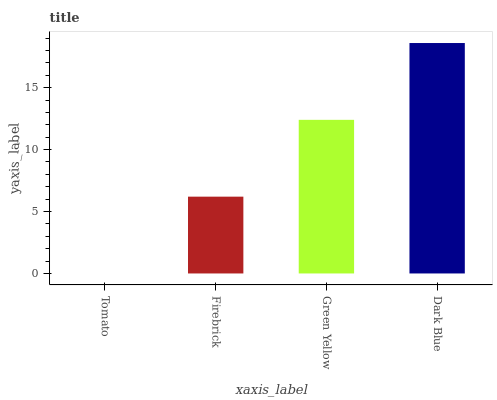Is Tomato the minimum?
Answer yes or no. Yes. Is Dark Blue the maximum?
Answer yes or no. Yes. Is Firebrick the minimum?
Answer yes or no. No. Is Firebrick the maximum?
Answer yes or no. No. Is Firebrick greater than Tomato?
Answer yes or no. Yes. Is Tomato less than Firebrick?
Answer yes or no. Yes. Is Tomato greater than Firebrick?
Answer yes or no. No. Is Firebrick less than Tomato?
Answer yes or no. No. Is Green Yellow the high median?
Answer yes or no. Yes. Is Firebrick the low median?
Answer yes or no. Yes. Is Tomato the high median?
Answer yes or no. No. Is Green Yellow the low median?
Answer yes or no. No. 